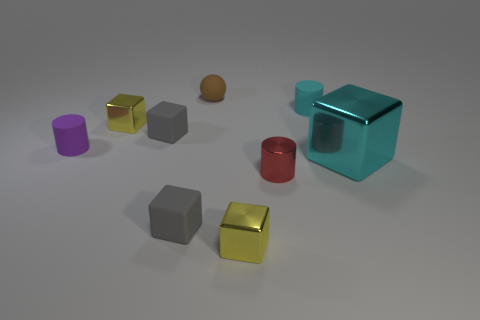There is a tiny cylinder that is the same color as the large thing; what is it made of?
Provide a short and direct response. Rubber. Do the large block and the tiny rubber cylinder that is behind the tiny purple matte cylinder have the same color?
Keep it short and to the point. Yes. What is the shape of the small cyan thing that is made of the same material as the purple cylinder?
Offer a terse response. Cylinder. How many things are tiny rubber cylinders or tiny red metallic objects?
Ensure brevity in your answer.  3. Are there any tiny rubber cylinders that have the same color as the big block?
Offer a terse response. Yes. Is the number of brown matte things less than the number of cyan spheres?
Provide a short and direct response. No. What number of objects are cyan cylinders or matte objects in front of the cyan rubber cylinder?
Make the answer very short. 4. Are there any tiny cyan cylinders that have the same material as the small brown thing?
Offer a terse response. Yes. There is a red object that is the same size as the cyan matte cylinder; what is it made of?
Offer a terse response. Metal. What is the material of the small yellow thing that is in front of the yellow cube that is behind the big shiny cube?
Offer a very short reply. Metal. 